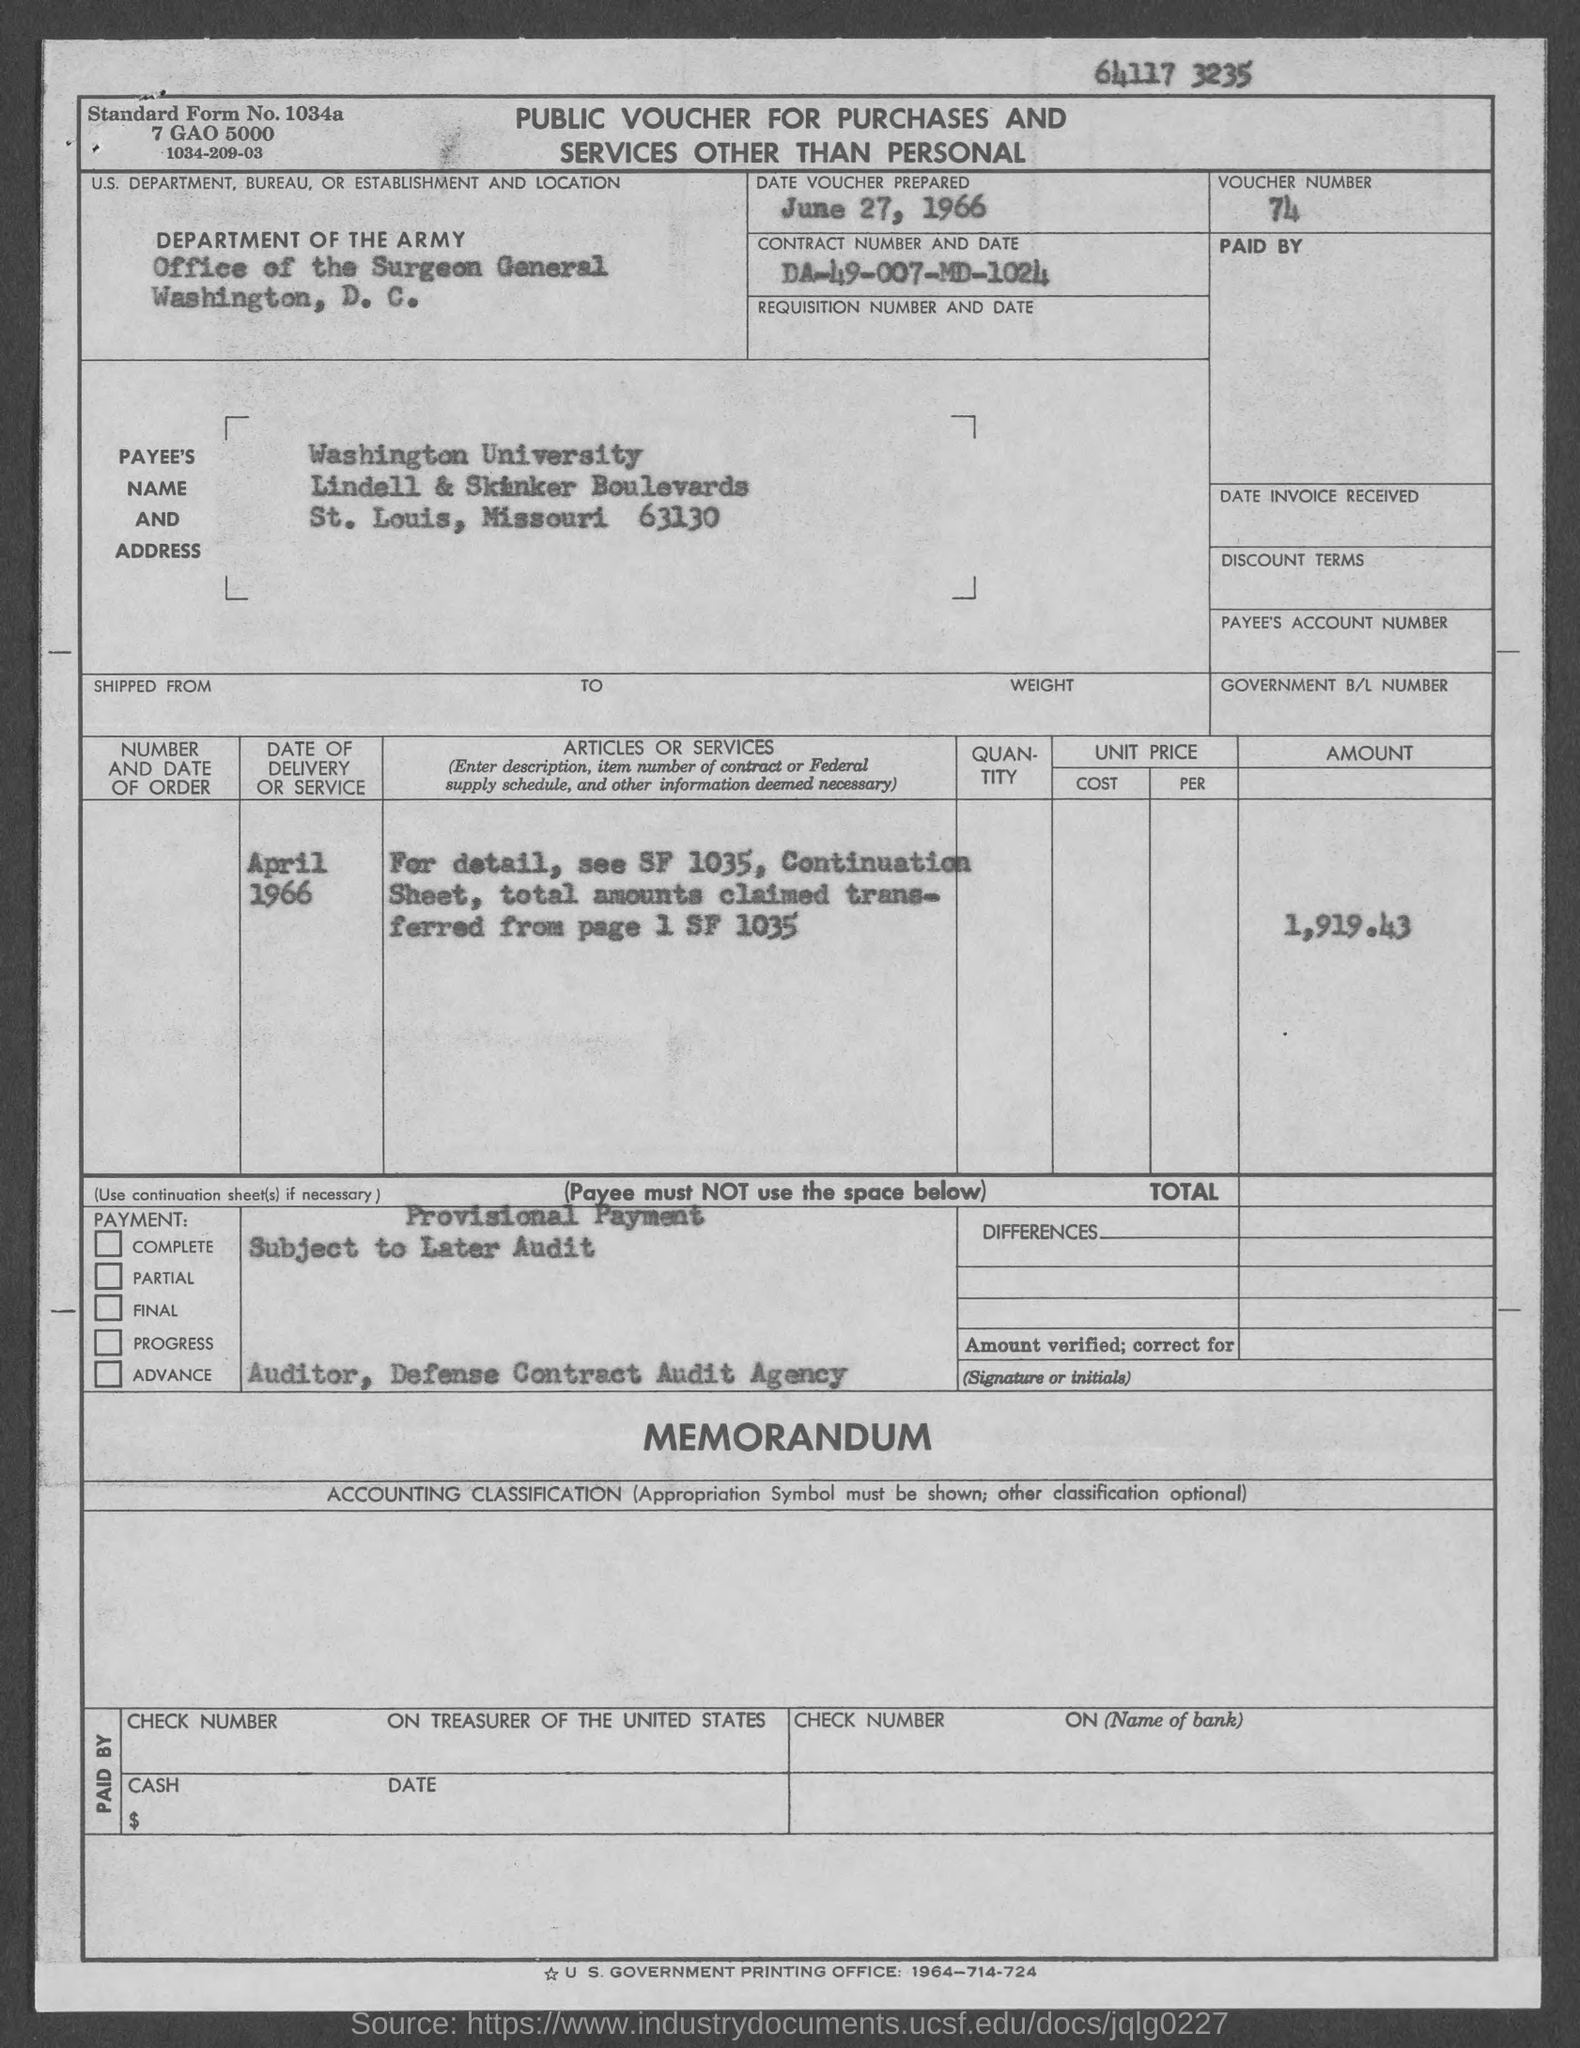What is the standard form no.?
Provide a succinct answer. 1034a. What is the number written at the top of the page?
Ensure brevity in your answer.  64117 3235. Which is the U.S. Department?
Your response must be concise. DEPARTMENT OF THE ARMY. On which date was voucher prepared?
Provide a succinct answer. June 27, 1966. What is voucher number?
Offer a terse response. 74. What is the contract number and date?
Offer a terse response. DA-49-007-MD-1024. What is the date of delivery or service?
Give a very brief answer. April 1966. What is the amount specified?
Keep it short and to the point. 1,919.43. 